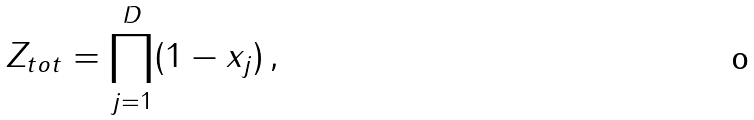<formula> <loc_0><loc_0><loc_500><loc_500>Z _ { t o t } = \prod _ { j = 1 } ^ { D } ( 1 - x _ { j } ) \, ,</formula> 